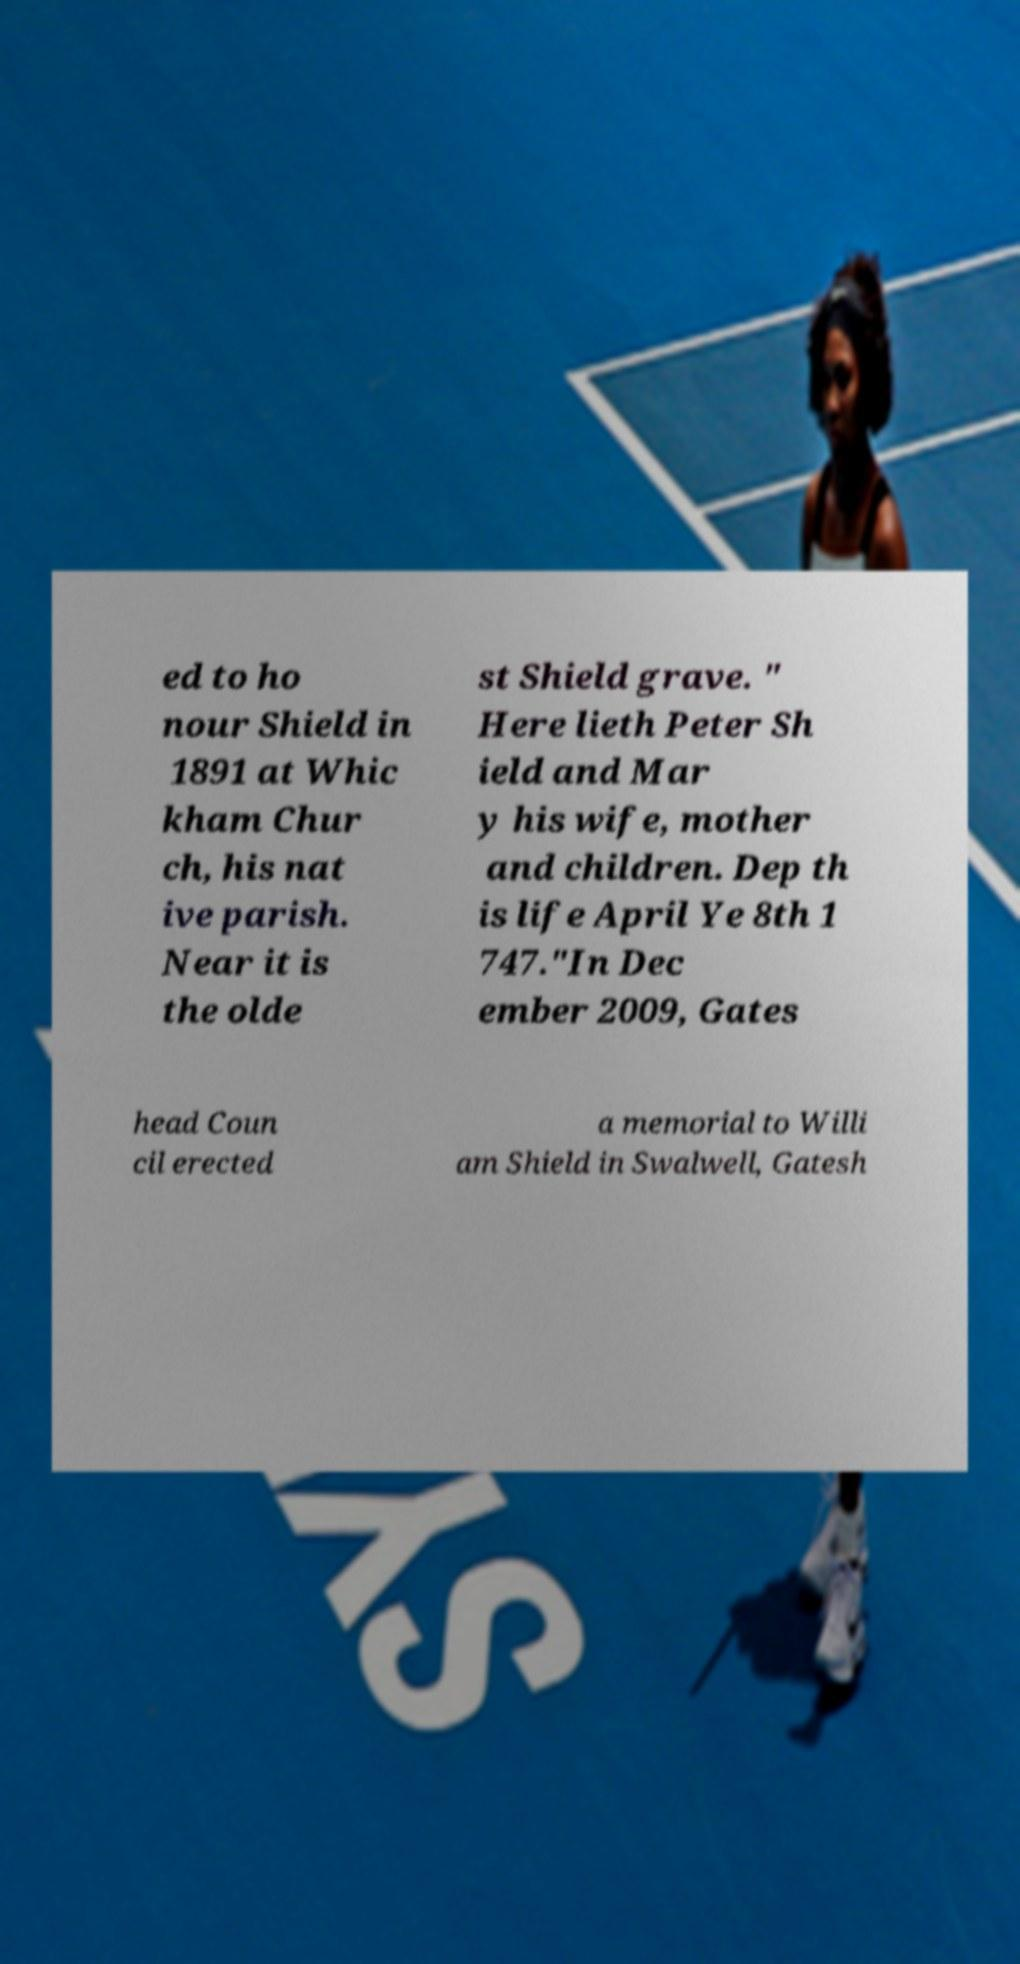What messages or text are displayed in this image? I need them in a readable, typed format. ed to ho nour Shield in 1891 at Whic kham Chur ch, his nat ive parish. Near it is the olde st Shield grave. " Here lieth Peter Sh ield and Mar y his wife, mother and children. Dep th is life April Ye 8th 1 747."In Dec ember 2009, Gates head Coun cil erected a memorial to Willi am Shield in Swalwell, Gatesh 